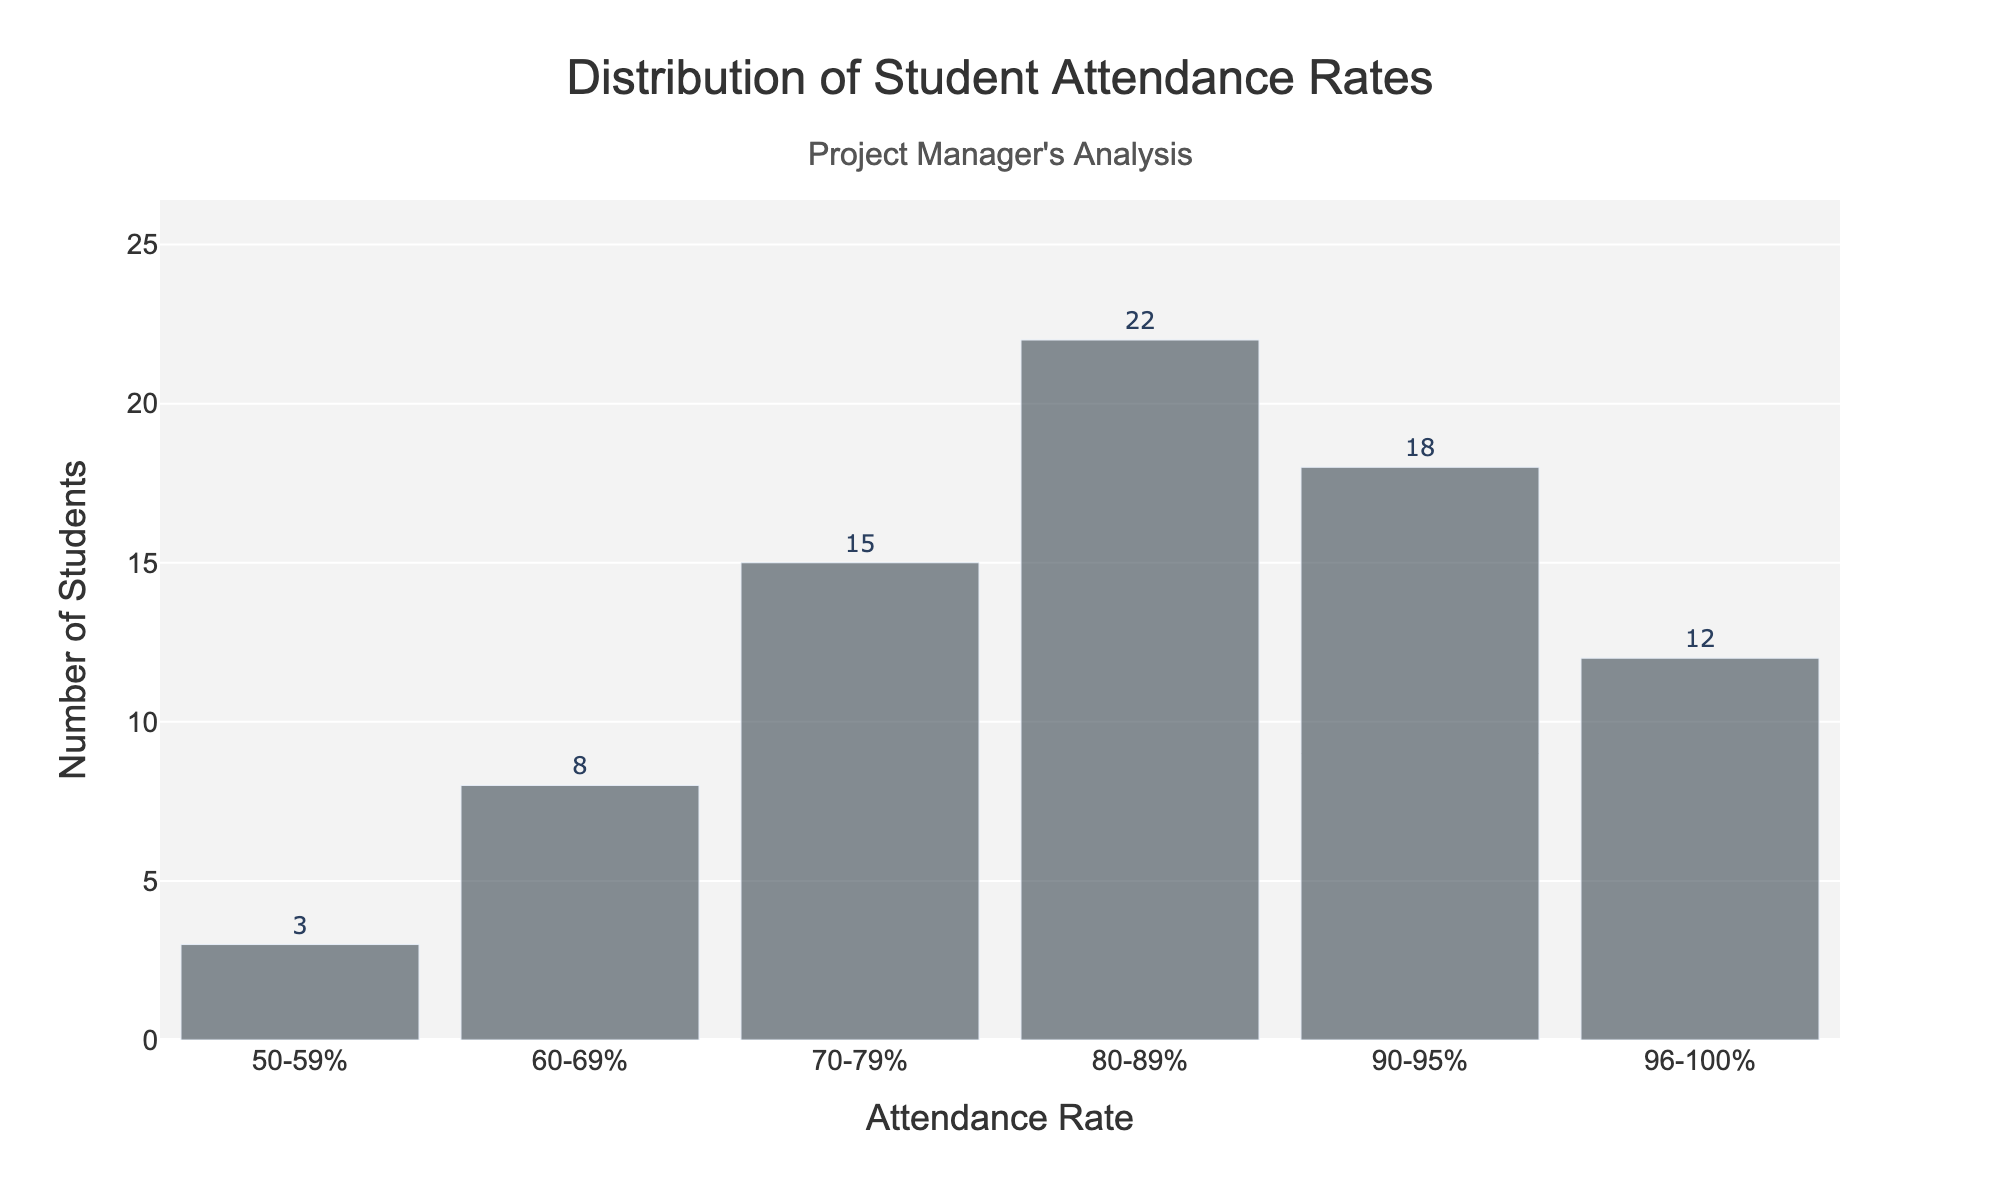What is the title of the figure? The title of the figure is displayed at the top and reads "Distribution of Student Attendance Rates".
Answer: Distribution of Student Attendance Rates How many students have an attendance rate between 80-89%? The figure shows the number of students for each attendance rate range. For the 80-89% range, the bar height and text indicate 22 students.
Answer: 22 Which attendance rate range has the highest number of students? By comparing the bar heights and the values displayed on each bar, the highest bar corresponds to the 80-89% attendance rate range with 22 students.
Answer: 80-89% What is the sum of students with attendance rates of 90-95% and 96-100%? Adding the number of students for the 90-95% range (18) and the 96-100% range (12) results in 18 + 12 = 30.
Answer: 30 What is the range of attendance rates that includes the majority of students? By observing the distribution of the bars, the majority of students fall in the 70-89% attendance rate ranges. Summing these up (15 for 70-79% and 22 for 80-89%) confirms this as 37 out of 78 total students.
Answer: 70-89% How many students are there in total? Adding the number of students across all attendance rate ranges: 3 + 8 + 15 + 22 + 18 + 12 = 78.
Answer: 78 Which attendance rate range has the lowest number of students? The bar with the smallest height and the smallest value corresponds to the 50-59% attendance rate range, which shows 3 students.
Answer: 50-59% Is the median attendance rate range above or below 80%? To find the median, arrange the segments cumulatively and find the middle value. The middle value lies in the attendance rate range 80-89% because the cumulative count until 70-79% is 26, and adding 22 (from 80-89%) reaches 48, which surpasses half of the total students (39 out of 78). Thus, the median is within the 80-89% range, above 80%.
Answer: Above 80% What is the average number of students per attendance rate range? The total number of students is 78. There are 6 attendance rate ranges, so the average number of students per range is 78 / 6 = 13.
Answer: 13 